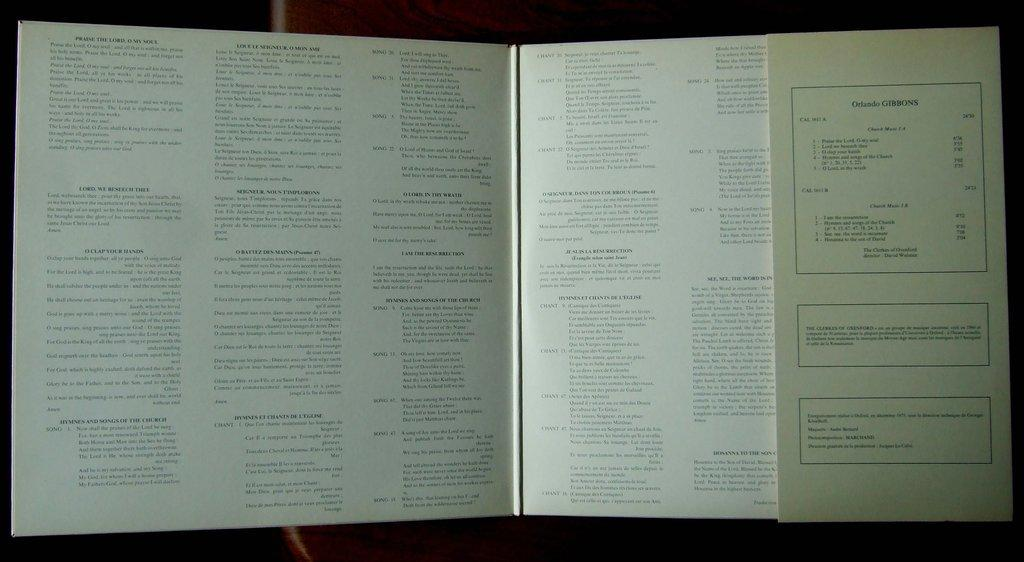<image>
Create a compact narrative representing the image presented. A open book with the words Praise the Lord at the top of the left pafe 